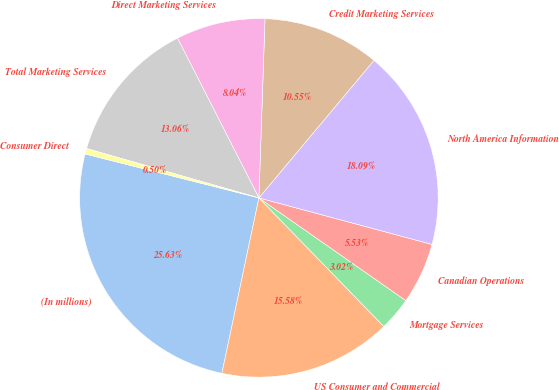Convert chart. <chart><loc_0><loc_0><loc_500><loc_500><pie_chart><fcel>(In millions)<fcel>US Consumer and Commercial<fcel>Mortgage Services<fcel>Canadian Operations<fcel>North America Information<fcel>Credit Marketing Services<fcel>Direct Marketing Services<fcel>Total Marketing Services<fcel>Consumer Direct<nl><fcel>25.63%<fcel>15.58%<fcel>3.02%<fcel>5.53%<fcel>18.09%<fcel>10.55%<fcel>8.04%<fcel>13.06%<fcel>0.5%<nl></chart> 